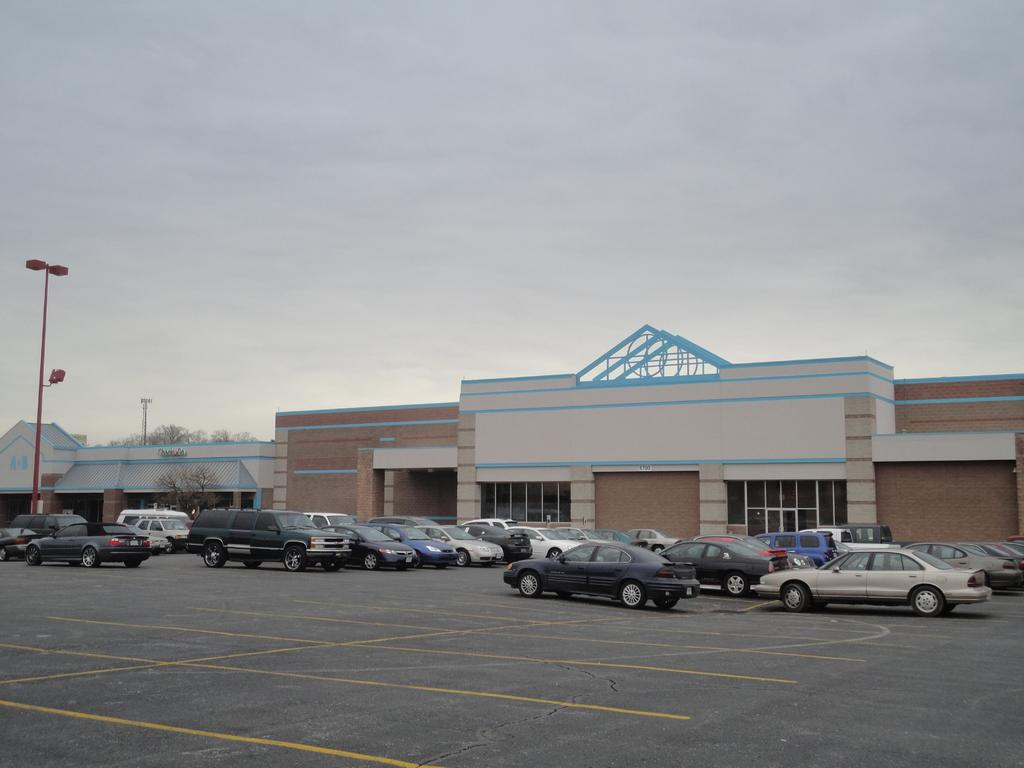What is located at the bottom of the image? There is a road at the bottom of the image. What can be seen on the road? There are cars on the road. What structures are present in the middle of the image? There are buildings in the middle of the image. What is visible at the top of the image? The sky is visible at the top of the image. Is there a board emitting steam in the image? No, there is no board or steam present in the image. Can you see a whip being used by someone in the image? No, there is no whip or person using a whip in the image. 